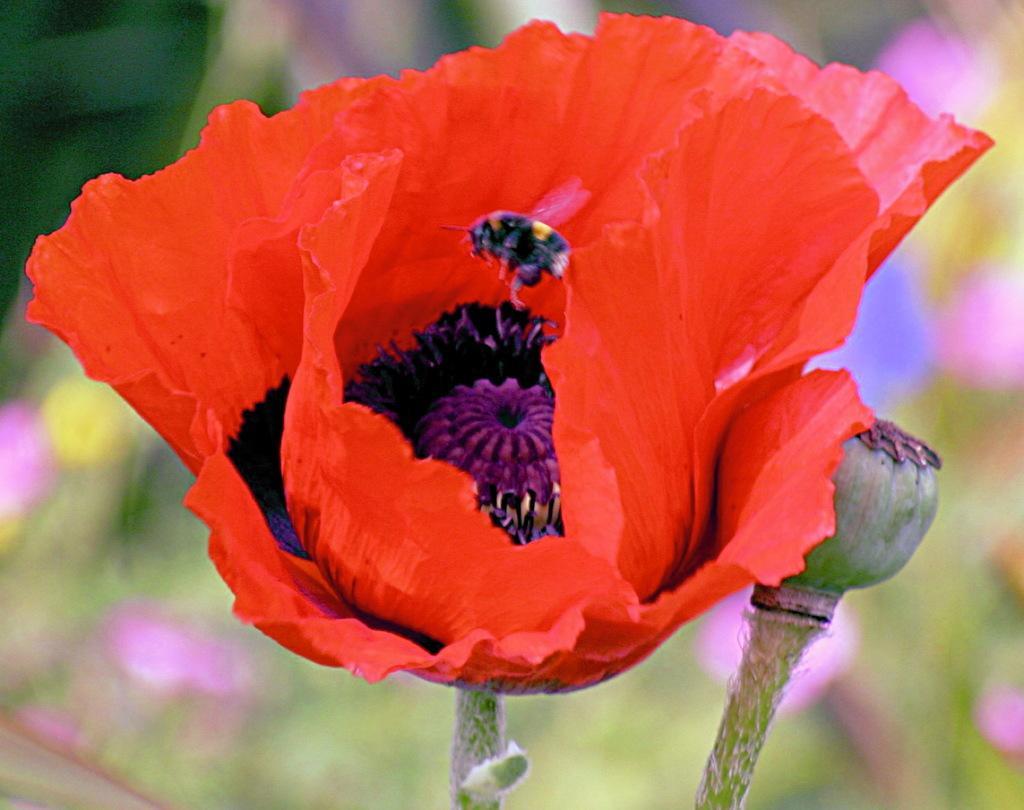Describe this image in one or two sentences. Here I can see a red color flowers and a bud along with the stems. On the flower there is a bee. The background is blurred. 